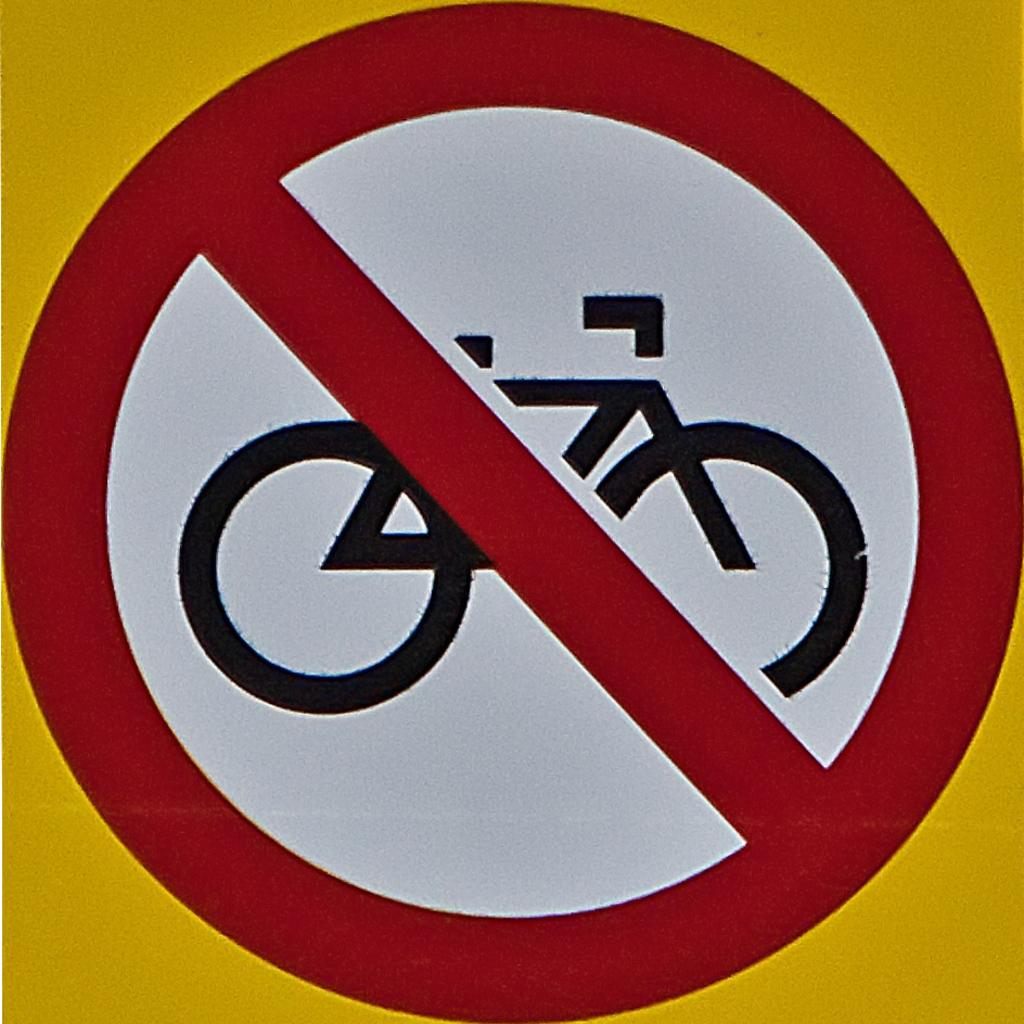What is the main subject in the foreground of the image? There is a stop sign board in the foreground of the image. What message does the sign board convey? The sign board states that no bicycles are allowed. What type of ant can be seen carrying a yoke in the image? There are no ants or yokes present in the image. What smell is associated with the image? The image does not convey any specific smell. 